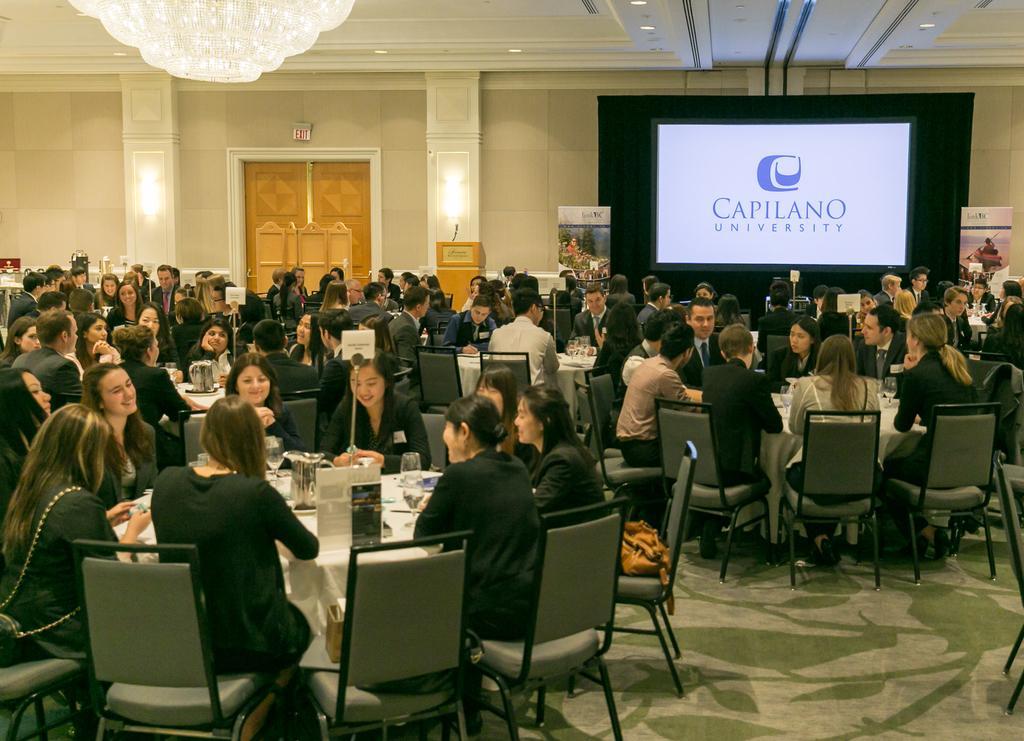Describe this image in one or two sentences. in this picture contains the many people they are sitting on the chair they are doing some thing work on the table and the table contains glasses,papers,mobiles behind the persons one big door is there and the background is white. 